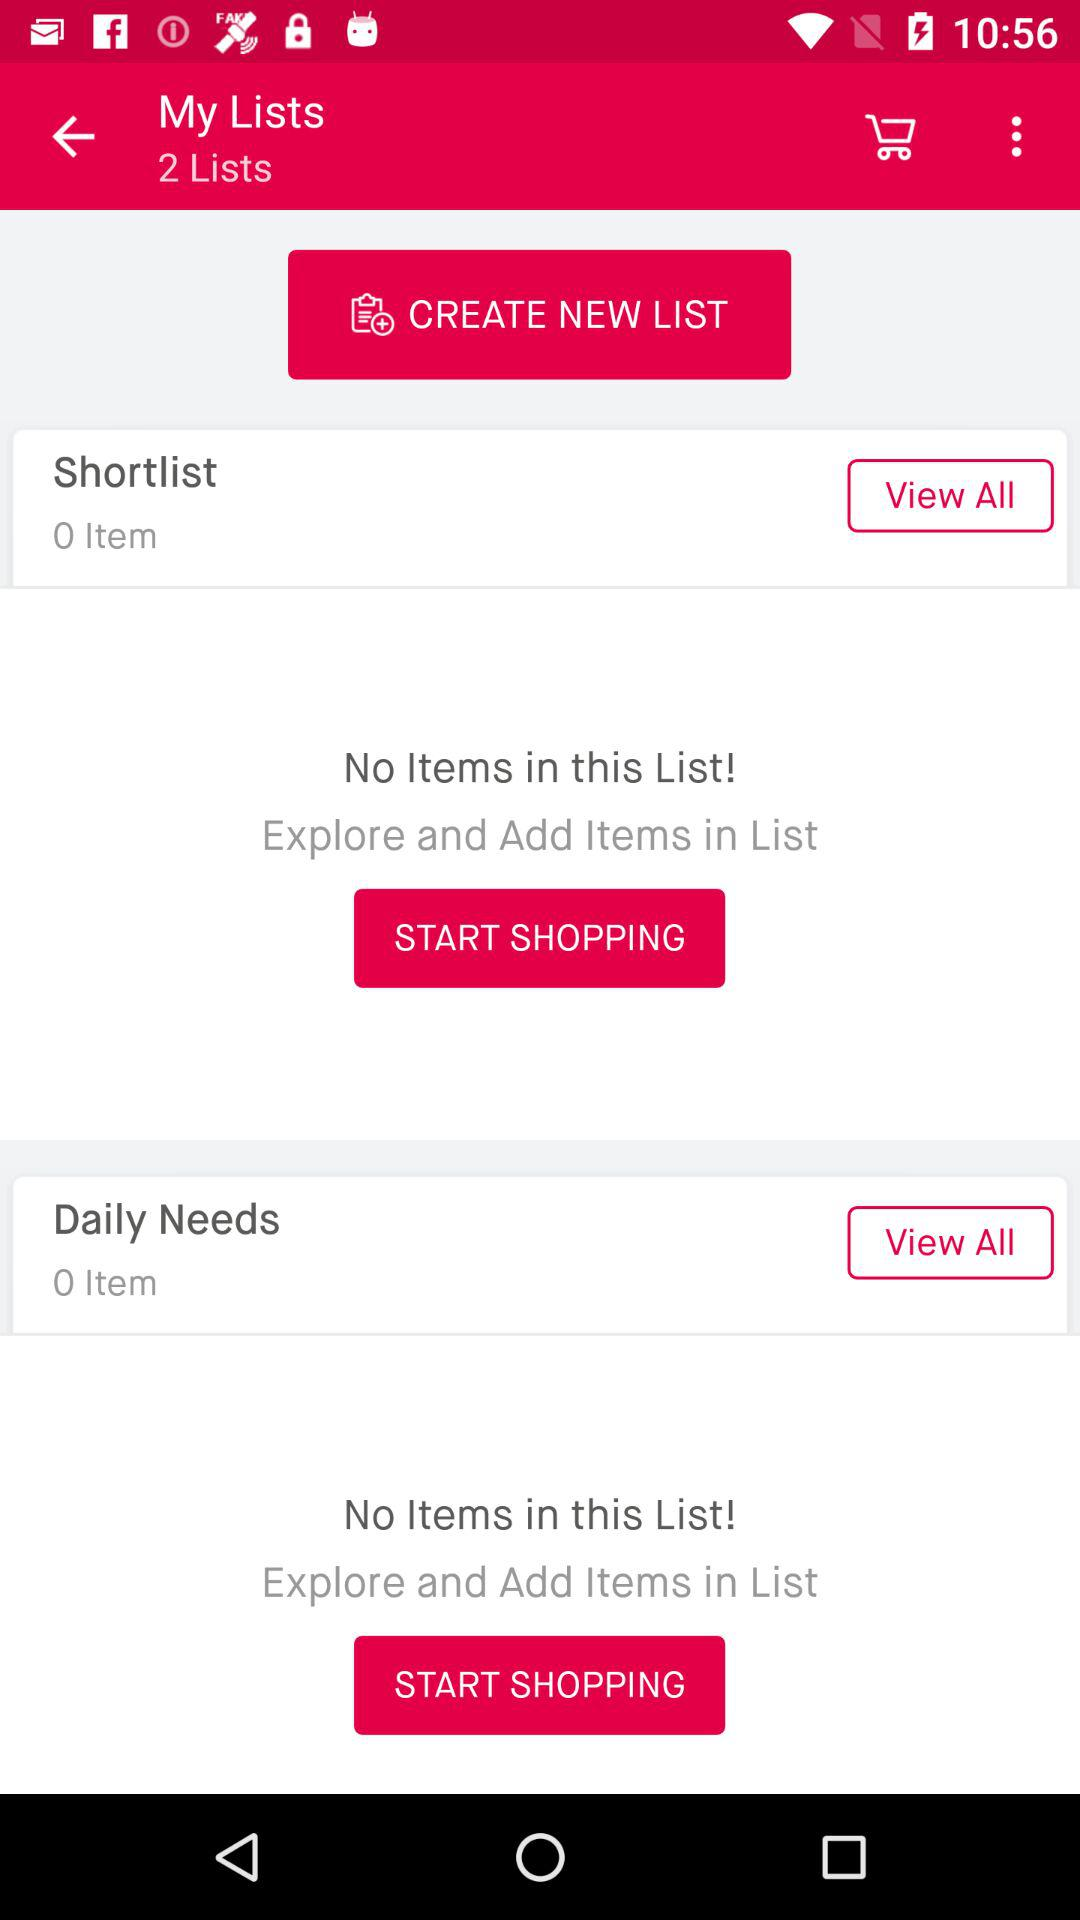How many items are on the shortlist? There are 0 items on the shortlist. 